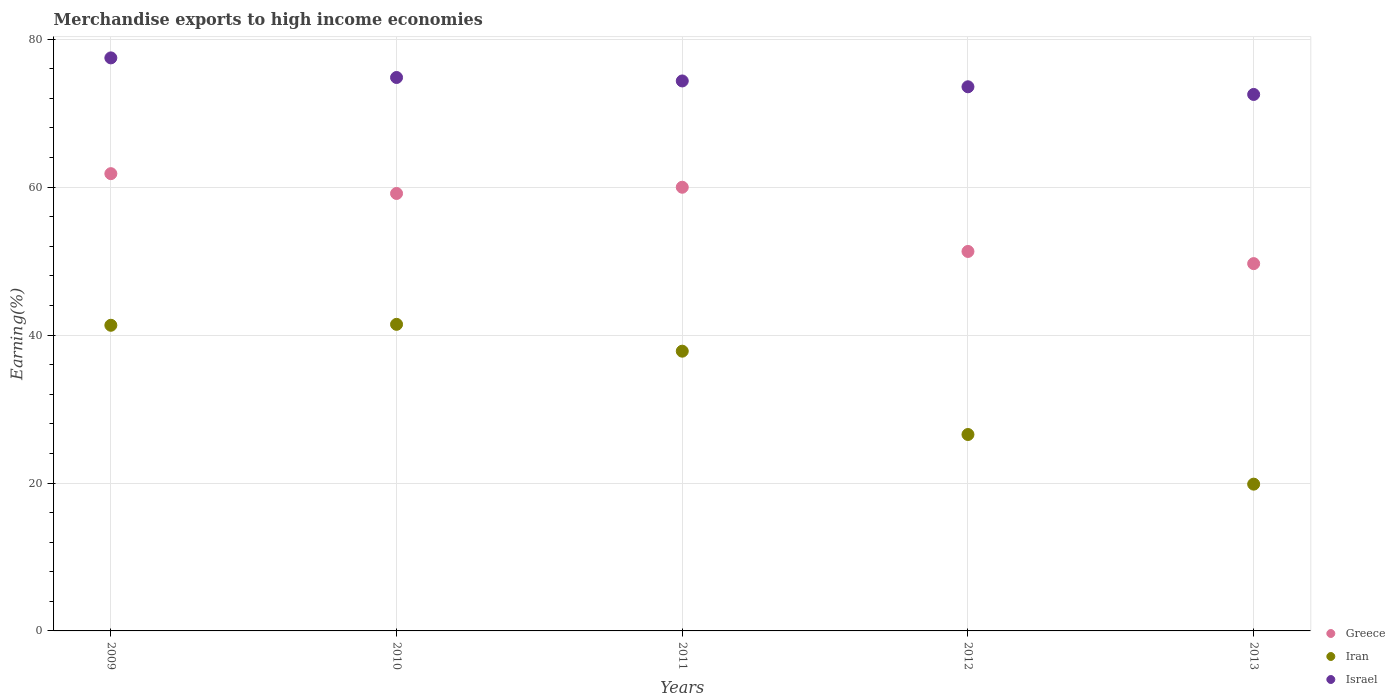Is the number of dotlines equal to the number of legend labels?
Provide a short and direct response. Yes. What is the percentage of amount earned from merchandise exports in Greece in 2009?
Make the answer very short. 61.83. Across all years, what is the maximum percentage of amount earned from merchandise exports in Israel?
Offer a very short reply. 77.48. Across all years, what is the minimum percentage of amount earned from merchandise exports in Iran?
Provide a succinct answer. 19.85. In which year was the percentage of amount earned from merchandise exports in Israel minimum?
Your response must be concise. 2013. What is the total percentage of amount earned from merchandise exports in Greece in the graph?
Your answer should be very brief. 281.94. What is the difference between the percentage of amount earned from merchandise exports in Greece in 2011 and that in 2013?
Offer a very short reply. 10.33. What is the difference between the percentage of amount earned from merchandise exports in Israel in 2013 and the percentage of amount earned from merchandise exports in Greece in 2009?
Your answer should be very brief. 10.71. What is the average percentage of amount earned from merchandise exports in Israel per year?
Ensure brevity in your answer.  74.56. In the year 2010, what is the difference between the percentage of amount earned from merchandise exports in Israel and percentage of amount earned from merchandise exports in Iran?
Provide a succinct answer. 33.38. What is the ratio of the percentage of amount earned from merchandise exports in Greece in 2011 to that in 2012?
Offer a terse response. 1.17. What is the difference between the highest and the second highest percentage of amount earned from merchandise exports in Iran?
Ensure brevity in your answer.  0.13. What is the difference between the highest and the lowest percentage of amount earned from merchandise exports in Iran?
Provide a short and direct response. 21.61. Is the percentage of amount earned from merchandise exports in Iran strictly greater than the percentage of amount earned from merchandise exports in Israel over the years?
Provide a short and direct response. No. How many dotlines are there?
Give a very brief answer. 3. What is the difference between two consecutive major ticks on the Y-axis?
Keep it short and to the point. 20. Are the values on the major ticks of Y-axis written in scientific E-notation?
Provide a short and direct response. No. Does the graph contain any zero values?
Your answer should be very brief. No. Does the graph contain grids?
Make the answer very short. Yes. Where does the legend appear in the graph?
Provide a short and direct response. Bottom right. How many legend labels are there?
Make the answer very short. 3. How are the legend labels stacked?
Your response must be concise. Vertical. What is the title of the graph?
Your answer should be very brief. Merchandise exports to high income economies. Does "Venezuela" appear as one of the legend labels in the graph?
Ensure brevity in your answer.  No. What is the label or title of the X-axis?
Offer a very short reply. Years. What is the label or title of the Y-axis?
Keep it short and to the point. Earning(%). What is the Earning(%) of Greece in 2009?
Give a very brief answer. 61.83. What is the Earning(%) of Iran in 2009?
Make the answer very short. 41.33. What is the Earning(%) in Israel in 2009?
Your answer should be very brief. 77.48. What is the Earning(%) of Greece in 2010?
Ensure brevity in your answer.  59.15. What is the Earning(%) in Iran in 2010?
Make the answer very short. 41.45. What is the Earning(%) in Israel in 2010?
Keep it short and to the point. 74.83. What is the Earning(%) in Greece in 2011?
Give a very brief answer. 59.99. What is the Earning(%) in Iran in 2011?
Keep it short and to the point. 37.82. What is the Earning(%) in Israel in 2011?
Offer a terse response. 74.36. What is the Earning(%) of Greece in 2012?
Your answer should be very brief. 51.31. What is the Earning(%) in Iran in 2012?
Make the answer very short. 26.56. What is the Earning(%) of Israel in 2012?
Your response must be concise. 73.57. What is the Earning(%) in Greece in 2013?
Offer a very short reply. 49.66. What is the Earning(%) in Iran in 2013?
Keep it short and to the point. 19.85. What is the Earning(%) in Israel in 2013?
Your response must be concise. 72.54. Across all years, what is the maximum Earning(%) in Greece?
Keep it short and to the point. 61.83. Across all years, what is the maximum Earning(%) in Iran?
Provide a short and direct response. 41.45. Across all years, what is the maximum Earning(%) in Israel?
Give a very brief answer. 77.48. Across all years, what is the minimum Earning(%) in Greece?
Ensure brevity in your answer.  49.66. Across all years, what is the minimum Earning(%) of Iran?
Offer a terse response. 19.85. Across all years, what is the minimum Earning(%) of Israel?
Keep it short and to the point. 72.54. What is the total Earning(%) in Greece in the graph?
Your answer should be very brief. 281.94. What is the total Earning(%) in Iran in the graph?
Offer a terse response. 167.01. What is the total Earning(%) in Israel in the graph?
Offer a terse response. 372.78. What is the difference between the Earning(%) of Greece in 2009 and that in 2010?
Make the answer very short. 2.68. What is the difference between the Earning(%) of Iran in 2009 and that in 2010?
Keep it short and to the point. -0.13. What is the difference between the Earning(%) in Israel in 2009 and that in 2010?
Your response must be concise. 2.65. What is the difference between the Earning(%) in Greece in 2009 and that in 2011?
Your answer should be compact. 1.84. What is the difference between the Earning(%) in Iran in 2009 and that in 2011?
Make the answer very short. 3.5. What is the difference between the Earning(%) in Israel in 2009 and that in 2011?
Offer a very short reply. 3.12. What is the difference between the Earning(%) of Greece in 2009 and that in 2012?
Your answer should be compact. 10.52. What is the difference between the Earning(%) of Iran in 2009 and that in 2012?
Your answer should be compact. 14.77. What is the difference between the Earning(%) in Israel in 2009 and that in 2012?
Keep it short and to the point. 3.91. What is the difference between the Earning(%) in Greece in 2009 and that in 2013?
Ensure brevity in your answer.  12.16. What is the difference between the Earning(%) in Iran in 2009 and that in 2013?
Make the answer very short. 21.48. What is the difference between the Earning(%) in Israel in 2009 and that in 2013?
Your answer should be very brief. 4.94. What is the difference between the Earning(%) of Greece in 2010 and that in 2011?
Keep it short and to the point. -0.84. What is the difference between the Earning(%) of Iran in 2010 and that in 2011?
Provide a short and direct response. 3.63. What is the difference between the Earning(%) in Israel in 2010 and that in 2011?
Provide a short and direct response. 0.47. What is the difference between the Earning(%) of Greece in 2010 and that in 2012?
Give a very brief answer. 7.84. What is the difference between the Earning(%) in Iran in 2010 and that in 2012?
Your response must be concise. 14.9. What is the difference between the Earning(%) in Israel in 2010 and that in 2012?
Your answer should be very brief. 1.26. What is the difference between the Earning(%) in Greece in 2010 and that in 2013?
Provide a short and direct response. 9.49. What is the difference between the Earning(%) in Iran in 2010 and that in 2013?
Provide a succinct answer. 21.61. What is the difference between the Earning(%) of Israel in 2010 and that in 2013?
Your answer should be very brief. 2.29. What is the difference between the Earning(%) in Greece in 2011 and that in 2012?
Your response must be concise. 8.68. What is the difference between the Earning(%) of Iran in 2011 and that in 2012?
Give a very brief answer. 11.27. What is the difference between the Earning(%) of Israel in 2011 and that in 2012?
Your answer should be compact. 0.79. What is the difference between the Earning(%) in Greece in 2011 and that in 2013?
Your answer should be compact. 10.33. What is the difference between the Earning(%) in Iran in 2011 and that in 2013?
Give a very brief answer. 17.98. What is the difference between the Earning(%) of Israel in 2011 and that in 2013?
Your answer should be very brief. 1.83. What is the difference between the Earning(%) of Greece in 2012 and that in 2013?
Your answer should be compact. 1.65. What is the difference between the Earning(%) of Iran in 2012 and that in 2013?
Your response must be concise. 6.71. What is the difference between the Earning(%) in Israel in 2012 and that in 2013?
Give a very brief answer. 1.04. What is the difference between the Earning(%) in Greece in 2009 and the Earning(%) in Iran in 2010?
Make the answer very short. 20.37. What is the difference between the Earning(%) in Greece in 2009 and the Earning(%) in Israel in 2010?
Your answer should be very brief. -13. What is the difference between the Earning(%) in Iran in 2009 and the Earning(%) in Israel in 2010?
Ensure brevity in your answer.  -33.5. What is the difference between the Earning(%) of Greece in 2009 and the Earning(%) of Iran in 2011?
Your answer should be very brief. 24. What is the difference between the Earning(%) in Greece in 2009 and the Earning(%) in Israel in 2011?
Your answer should be compact. -12.53. What is the difference between the Earning(%) of Iran in 2009 and the Earning(%) of Israel in 2011?
Provide a succinct answer. -33.03. What is the difference between the Earning(%) in Greece in 2009 and the Earning(%) in Iran in 2012?
Ensure brevity in your answer.  35.27. What is the difference between the Earning(%) in Greece in 2009 and the Earning(%) in Israel in 2012?
Your response must be concise. -11.75. What is the difference between the Earning(%) in Iran in 2009 and the Earning(%) in Israel in 2012?
Keep it short and to the point. -32.25. What is the difference between the Earning(%) of Greece in 2009 and the Earning(%) of Iran in 2013?
Your answer should be compact. 41.98. What is the difference between the Earning(%) in Greece in 2009 and the Earning(%) in Israel in 2013?
Offer a very short reply. -10.71. What is the difference between the Earning(%) in Iran in 2009 and the Earning(%) in Israel in 2013?
Ensure brevity in your answer.  -31.21. What is the difference between the Earning(%) in Greece in 2010 and the Earning(%) in Iran in 2011?
Give a very brief answer. 21.32. What is the difference between the Earning(%) in Greece in 2010 and the Earning(%) in Israel in 2011?
Offer a very short reply. -15.21. What is the difference between the Earning(%) of Iran in 2010 and the Earning(%) of Israel in 2011?
Offer a terse response. -32.91. What is the difference between the Earning(%) of Greece in 2010 and the Earning(%) of Iran in 2012?
Provide a short and direct response. 32.59. What is the difference between the Earning(%) in Greece in 2010 and the Earning(%) in Israel in 2012?
Your answer should be compact. -14.43. What is the difference between the Earning(%) of Iran in 2010 and the Earning(%) of Israel in 2012?
Your answer should be very brief. -32.12. What is the difference between the Earning(%) in Greece in 2010 and the Earning(%) in Iran in 2013?
Ensure brevity in your answer.  39.3. What is the difference between the Earning(%) in Greece in 2010 and the Earning(%) in Israel in 2013?
Offer a terse response. -13.39. What is the difference between the Earning(%) in Iran in 2010 and the Earning(%) in Israel in 2013?
Provide a short and direct response. -31.08. What is the difference between the Earning(%) in Greece in 2011 and the Earning(%) in Iran in 2012?
Your answer should be compact. 33.43. What is the difference between the Earning(%) in Greece in 2011 and the Earning(%) in Israel in 2012?
Your answer should be compact. -13.58. What is the difference between the Earning(%) in Iran in 2011 and the Earning(%) in Israel in 2012?
Provide a short and direct response. -35.75. What is the difference between the Earning(%) in Greece in 2011 and the Earning(%) in Iran in 2013?
Provide a short and direct response. 40.14. What is the difference between the Earning(%) of Greece in 2011 and the Earning(%) of Israel in 2013?
Give a very brief answer. -12.55. What is the difference between the Earning(%) in Iran in 2011 and the Earning(%) in Israel in 2013?
Your response must be concise. -34.71. What is the difference between the Earning(%) in Greece in 2012 and the Earning(%) in Iran in 2013?
Offer a very short reply. 31.46. What is the difference between the Earning(%) in Greece in 2012 and the Earning(%) in Israel in 2013?
Your answer should be very brief. -21.23. What is the difference between the Earning(%) in Iran in 2012 and the Earning(%) in Israel in 2013?
Ensure brevity in your answer.  -45.98. What is the average Earning(%) in Greece per year?
Make the answer very short. 56.39. What is the average Earning(%) in Iran per year?
Your response must be concise. 33.4. What is the average Earning(%) of Israel per year?
Offer a terse response. 74.56. In the year 2009, what is the difference between the Earning(%) of Greece and Earning(%) of Iran?
Your response must be concise. 20.5. In the year 2009, what is the difference between the Earning(%) of Greece and Earning(%) of Israel?
Provide a succinct answer. -15.65. In the year 2009, what is the difference between the Earning(%) of Iran and Earning(%) of Israel?
Provide a succinct answer. -36.15. In the year 2010, what is the difference between the Earning(%) of Greece and Earning(%) of Iran?
Offer a terse response. 17.7. In the year 2010, what is the difference between the Earning(%) in Greece and Earning(%) in Israel?
Provide a short and direct response. -15.68. In the year 2010, what is the difference between the Earning(%) of Iran and Earning(%) of Israel?
Provide a short and direct response. -33.38. In the year 2011, what is the difference between the Earning(%) of Greece and Earning(%) of Iran?
Provide a short and direct response. 22.17. In the year 2011, what is the difference between the Earning(%) in Greece and Earning(%) in Israel?
Your response must be concise. -14.37. In the year 2011, what is the difference between the Earning(%) in Iran and Earning(%) in Israel?
Provide a succinct answer. -36.54. In the year 2012, what is the difference between the Earning(%) of Greece and Earning(%) of Iran?
Provide a short and direct response. 24.75. In the year 2012, what is the difference between the Earning(%) of Greece and Earning(%) of Israel?
Give a very brief answer. -22.26. In the year 2012, what is the difference between the Earning(%) of Iran and Earning(%) of Israel?
Your answer should be very brief. -47.02. In the year 2013, what is the difference between the Earning(%) of Greece and Earning(%) of Iran?
Your answer should be very brief. 29.82. In the year 2013, what is the difference between the Earning(%) in Greece and Earning(%) in Israel?
Ensure brevity in your answer.  -22.87. In the year 2013, what is the difference between the Earning(%) in Iran and Earning(%) in Israel?
Your response must be concise. -52.69. What is the ratio of the Earning(%) of Greece in 2009 to that in 2010?
Offer a terse response. 1.05. What is the ratio of the Earning(%) in Israel in 2009 to that in 2010?
Your answer should be very brief. 1.04. What is the ratio of the Earning(%) of Greece in 2009 to that in 2011?
Offer a very short reply. 1.03. What is the ratio of the Earning(%) of Iran in 2009 to that in 2011?
Your answer should be very brief. 1.09. What is the ratio of the Earning(%) in Israel in 2009 to that in 2011?
Make the answer very short. 1.04. What is the ratio of the Earning(%) of Greece in 2009 to that in 2012?
Your answer should be compact. 1.21. What is the ratio of the Earning(%) of Iran in 2009 to that in 2012?
Keep it short and to the point. 1.56. What is the ratio of the Earning(%) in Israel in 2009 to that in 2012?
Your answer should be very brief. 1.05. What is the ratio of the Earning(%) in Greece in 2009 to that in 2013?
Your answer should be compact. 1.24. What is the ratio of the Earning(%) of Iran in 2009 to that in 2013?
Your answer should be very brief. 2.08. What is the ratio of the Earning(%) of Israel in 2009 to that in 2013?
Offer a terse response. 1.07. What is the ratio of the Earning(%) in Greece in 2010 to that in 2011?
Your response must be concise. 0.99. What is the ratio of the Earning(%) of Iran in 2010 to that in 2011?
Keep it short and to the point. 1.1. What is the ratio of the Earning(%) of Israel in 2010 to that in 2011?
Offer a terse response. 1.01. What is the ratio of the Earning(%) of Greece in 2010 to that in 2012?
Provide a short and direct response. 1.15. What is the ratio of the Earning(%) in Iran in 2010 to that in 2012?
Ensure brevity in your answer.  1.56. What is the ratio of the Earning(%) in Israel in 2010 to that in 2012?
Give a very brief answer. 1.02. What is the ratio of the Earning(%) in Greece in 2010 to that in 2013?
Give a very brief answer. 1.19. What is the ratio of the Earning(%) of Iran in 2010 to that in 2013?
Your answer should be compact. 2.09. What is the ratio of the Earning(%) of Israel in 2010 to that in 2013?
Your answer should be compact. 1.03. What is the ratio of the Earning(%) of Greece in 2011 to that in 2012?
Offer a terse response. 1.17. What is the ratio of the Earning(%) in Iran in 2011 to that in 2012?
Your response must be concise. 1.42. What is the ratio of the Earning(%) of Israel in 2011 to that in 2012?
Your answer should be very brief. 1.01. What is the ratio of the Earning(%) in Greece in 2011 to that in 2013?
Provide a short and direct response. 1.21. What is the ratio of the Earning(%) of Iran in 2011 to that in 2013?
Offer a very short reply. 1.91. What is the ratio of the Earning(%) of Israel in 2011 to that in 2013?
Your answer should be compact. 1.03. What is the ratio of the Earning(%) in Greece in 2012 to that in 2013?
Your response must be concise. 1.03. What is the ratio of the Earning(%) in Iran in 2012 to that in 2013?
Your answer should be very brief. 1.34. What is the ratio of the Earning(%) in Israel in 2012 to that in 2013?
Provide a succinct answer. 1.01. What is the difference between the highest and the second highest Earning(%) of Greece?
Offer a terse response. 1.84. What is the difference between the highest and the second highest Earning(%) of Iran?
Your answer should be compact. 0.13. What is the difference between the highest and the second highest Earning(%) in Israel?
Your answer should be very brief. 2.65. What is the difference between the highest and the lowest Earning(%) of Greece?
Keep it short and to the point. 12.16. What is the difference between the highest and the lowest Earning(%) of Iran?
Offer a terse response. 21.61. What is the difference between the highest and the lowest Earning(%) of Israel?
Your response must be concise. 4.94. 